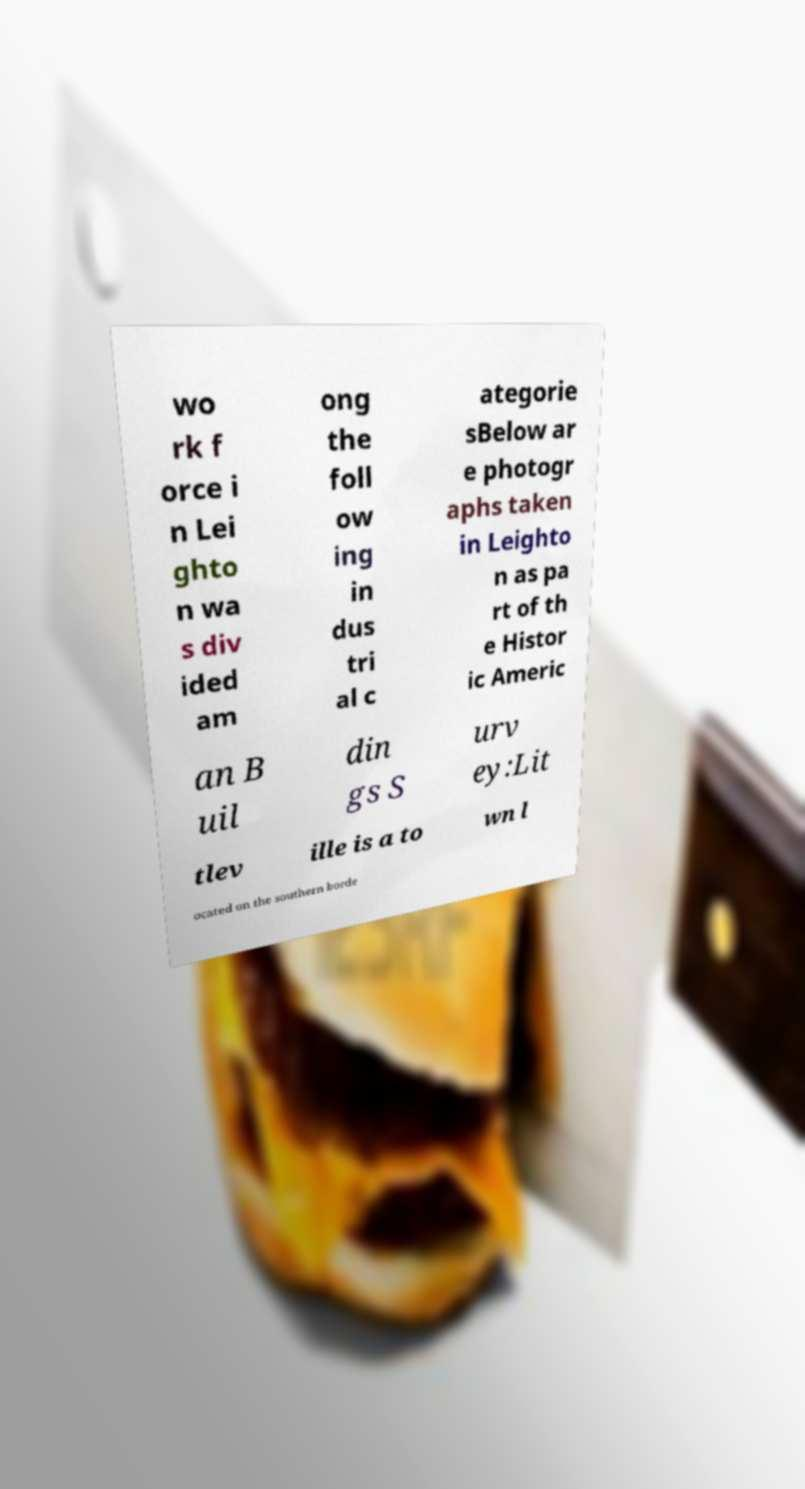Could you extract and type out the text from this image? wo rk f orce i n Lei ghto n wa s div ided am ong the foll ow ing in dus tri al c ategorie sBelow ar e photogr aphs taken in Leighto n as pa rt of th e Histor ic Americ an B uil din gs S urv ey:Lit tlev ille is a to wn l ocated on the southern borde 